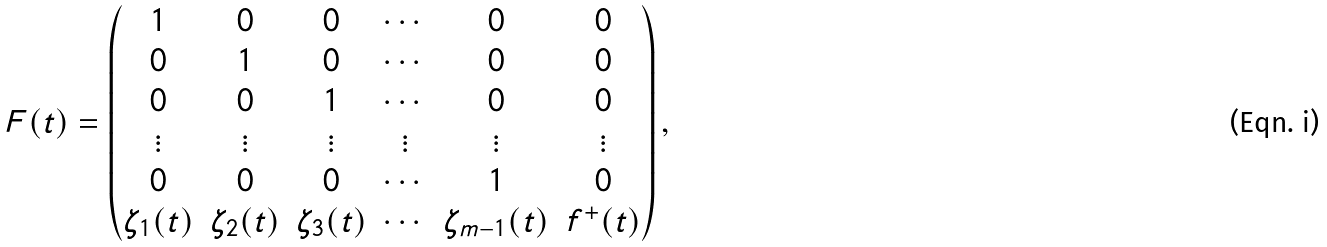Convert formula to latex. <formula><loc_0><loc_0><loc_500><loc_500>F ( t ) = \begin{pmatrix} 1 & 0 & 0 & \cdots & 0 & 0 \\ 0 & 1 & 0 & \cdots & 0 & 0 \\ 0 & 0 & 1 & \cdots & 0 & 0 \\ \vdots & \vdots & \vdots & \vdots & \vdots & \vdots \\ 0 & 0 & 0 & \cdots & 1 & 0 \\ \zeta _ { 1 } ( t ) & \zeta _ { 2 } ( t ) & \zeta _ { 3 } ( t ) & \cdots & \zeta _ { m - 1 } ( t ) & f ^ { + } ( t ) \end{pmatrix} ,</formula> 